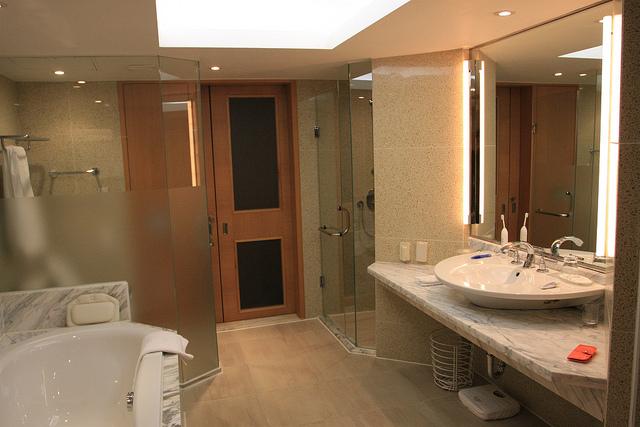Do you see a bathroom scale?
Quick response, please. Yes. What is the countertop made of?
Answer briefly. Marble. What is next to the trash bin?
Quick response, please. Scale. 